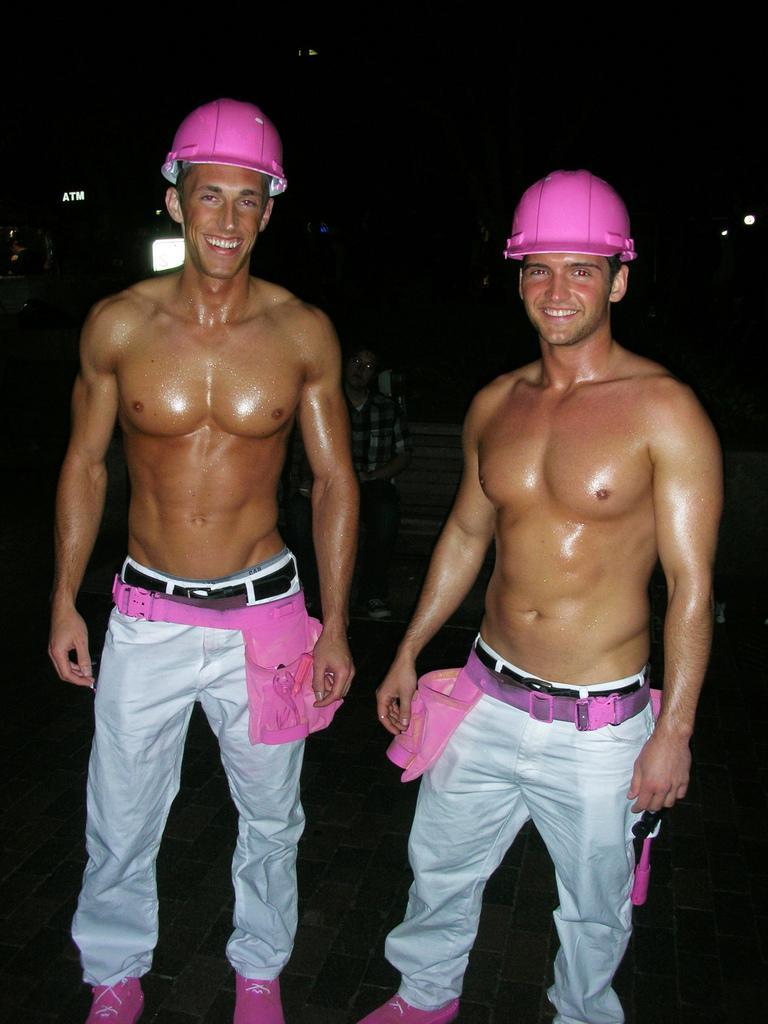In one or two sentences, can you explain what this image depicts? In this image we can see two persons wearing pink color helmets, white color pants and pink color shoes are standing here and smiling. The background of the image is blurred, where we can see a person sitting on the chair. 